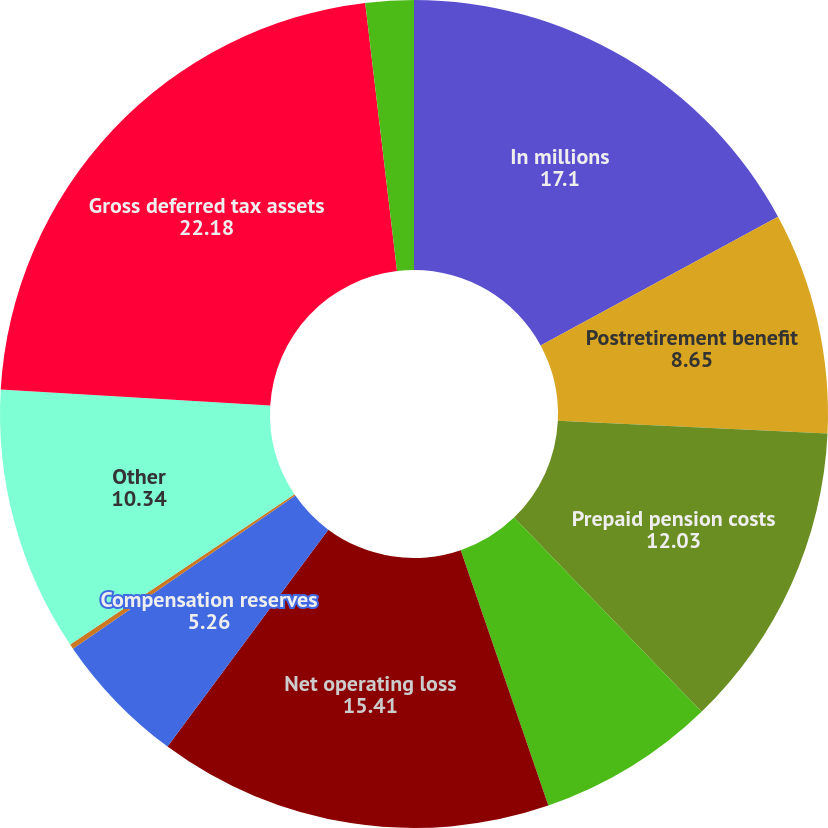Convert chart. <chart><loc_0><loc_0><loc_500><loc_500><pie_chart><fcel>In millions<fcel>Postretirement benefit<fcel>Prepaid pension costs<fcel>Alternative minimum and other<fcel>Net operating loss<fcel>Compensation reserves<fcel>Legal reserves<fcel>Other<fcel>Gross deferred tax assets<fcel>Less valuation allowance<nl><fcel>17.1%<fcel>8.65%<fcel>12.03%<fcel>6.96%<fcel>15.41%<fcel>5.26%<fcel>0.19%<fcel>10.34%<fcel>22.18%<fcel>1.88%<nl></chart> 